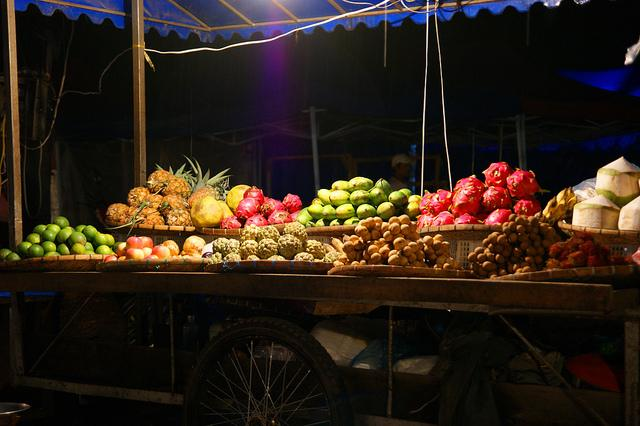What would you call this type of fruit seller?

Choices:
A) retailer
B) merchant
C) grocer
D) street vendor street vendor 